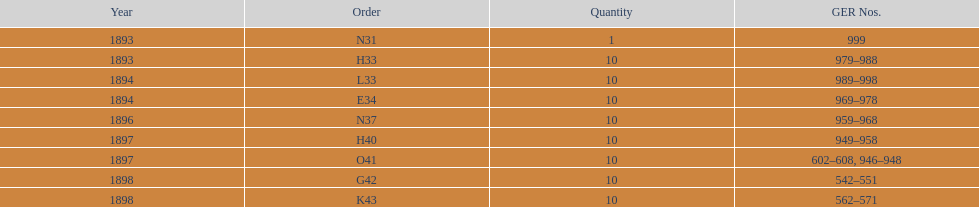How mans years have ger nos below 900? 2. 